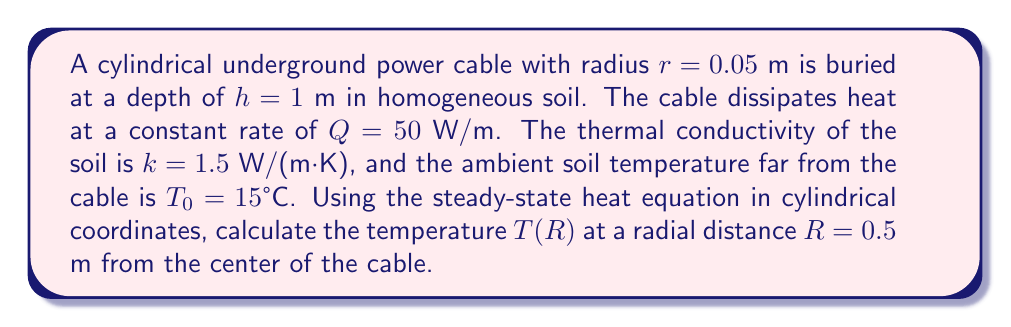Can you solve this math problem? To solve this problem, we'll follow these steps:

1) The steady-state heat equation in cylindrical coordinates for a line source is:

   $$\frac{1}{r}\frac{d}{dr}\left(r\frac{dT}{dr}\right) = 0$$

2) Integrating once:

   $$r\frac{dT}{dr} = C_1$$

3) Integrating again:

   $$T(r) = C_1 \ln(r) + C_2$$

4) We can determine $C_1$ using the heat flux condition at the cable surface:

   $$-k\frac{dT}{dr}\bigg|_{r=r_0} = \frac{Q}{2\pi r_0}$$

   $$C_1 = -\frac{Q}{2\pi k}$$

5) Substituting back:

   $$T(r) = -\frac{Q}{2\pi k}\ln(r) + C_2$$

6) To find $C_2$, we use the boundary condition that $T(\infty) = T_0$:

   $$T_0 = -\frac{Q}{2\pi k}\ln(\infty) + C_2$$

   As $\ln(\infty)$ approaches infinity, $C_2$ must also approach infinity to keep $T_0$ finite. We can rewrite the equation as:

   $$T(r) = T_0 + \frac{Q}{2\pi k}\ln\left(\frac{r_\infty}{r}\right)$$

   Where $r_\infty$ is some large distance where $T \approx T_0$.

7) Now we can calculate $T(R)$:

   $$T(R) = T_0 + \frac{Q}{2\pi k}\ln\left(\frac{r_\infty}{R}\right)$$

8) Substituting the given values:

   $$T(0.5) = 15 + \frac{50}{2\pi \cdot 1.5}\ln\left(\frac{r_\infty}{0.5}\right)$$

9) To determine $r_\infty$, we can use the cable depth $h$:

   $$r_\infty \approx 2h = 2 \cdot 1 = 2\text{ m}$$

10) Finally, calculating:

    $$T(0.5) = 15 + \frac{50}{2\pi \cdot 1.5}\ln\left(\frac{2}{0.5}\right) \approx 20.37°C$$
Answer: $20.37°C$ 